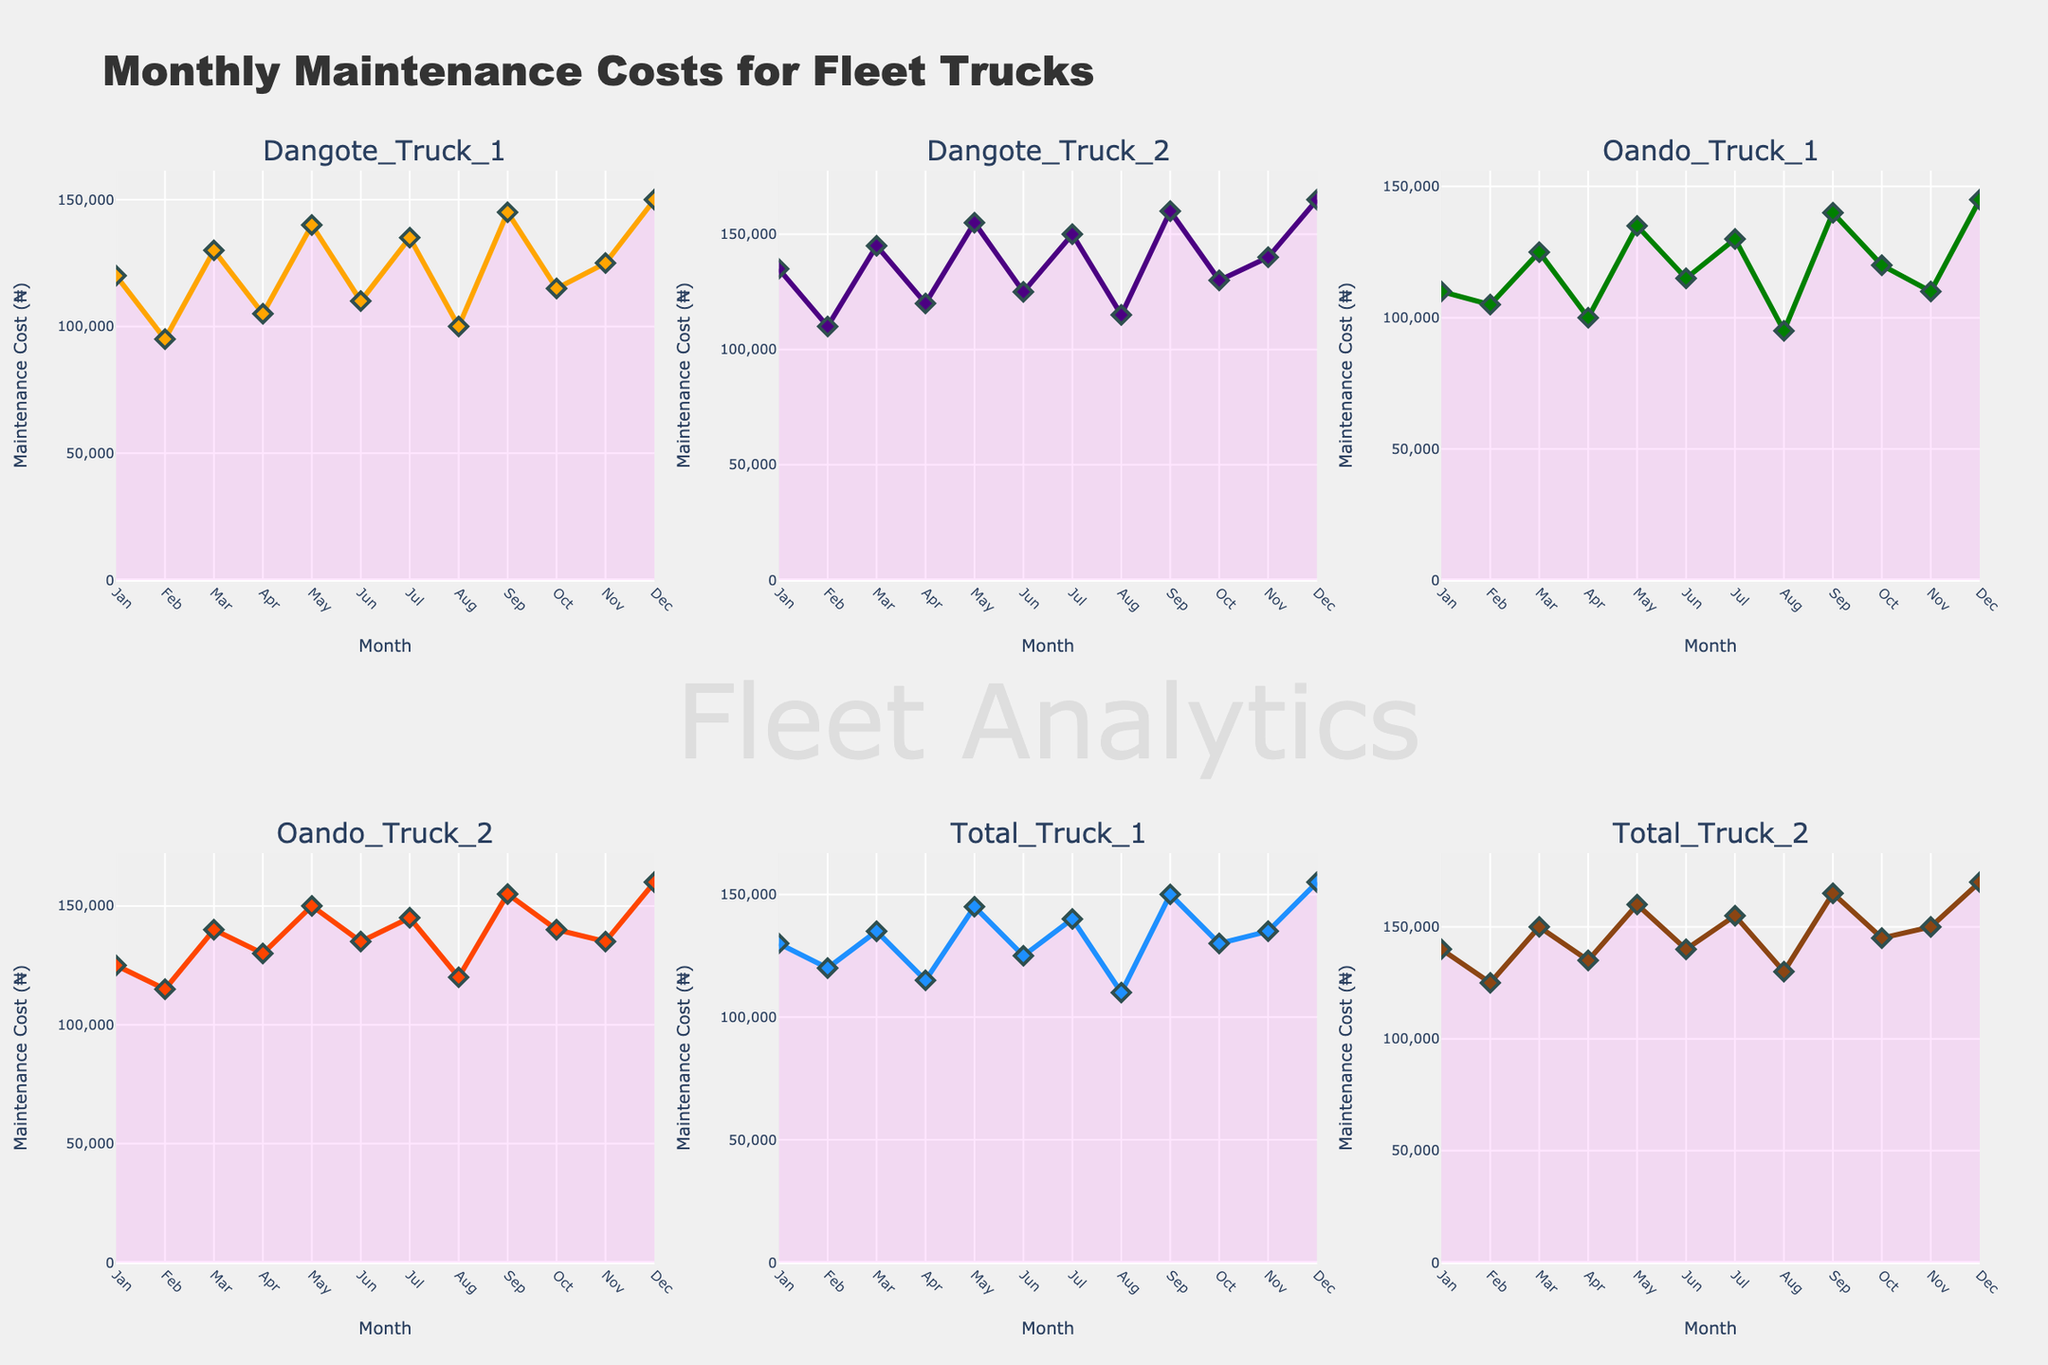What's the title of the chart? The title of the chart can be found at the top of the figure. In this case, it reads "Monthly Maintenance Costs for Fleet Trucks".
Answer: Monthly Maintenance Costs for Fleet Trucks Which truck had the highest maintenance cost in December? By looking at the subplot for December and comparing the values for each truck, you will see that "Total_Truck_2" shows the highest maintenance cost.
Answer: Total_Truck_2 What is the general trend of "Dangote_Truck_1" maintenance cost over the year? Observe the "Dangote_Truck_1" subplot and trace the line from January to December. The trend shows fluctuations, with costs peaking in March and lowest in February and August.
Answer: Fluctuating with peaks in March and lowest in February and August Between March and June, which truck had a more significant decrease in maintenance costs, "Oando_Truck_2" or "Total_Truck_2"? Calculate the difference in maintenance costs for both trucks between March and June. "Oando_Truck_2" drops from 140,000 to 135,000 (5,000), whereas "Total_Truck_2" drops from 150,000 to 140,000 (10,000).
Answer: Total_Truck_2 Which months had the lowest maintenance costs for "Total_Truck_1"? Examine the "Total_Truck_1" subplot and identify the months with the smallest y-values. "Total_Truck_1" has the lowest costs in February and August.
Answer: February and August How do the maintenance costs of the two "Oando" trucks compare in May? Compare the maintenance cost values for "Oando_Truck_1" and "Oando_Truck_2" in the May subplot. "Oando_Truck_1" has 135,000, and "Oando_Truck_2" has 150,000.
Answer: Oando_Truck_2 is higher What is the average maintenance cost for "Dangote_Truck_2" over the year? Sum up the monthly costs for "Dangote_Truck_2" and divide by the number of months (12). The total is 155,000 + 110,000 + 145,000 + 120,000 + 155,000 + 125,000 + 150,000 + 115,000 + 160,000 + 130,000 + 140,000 + 165,000 = 1,670,000. The average is 1,670,000 / 12.
Answer: 139,167 Which truck had the most considerable increase in maintenance costs from August to September? Calculate the increase for each truck by subtracting the August cost from the September cost. Identify the truck with the highest increase. "Oando_Truck_1" goes from 95,000 to 140,000 (45,000 increase).
Answer: Oando_Truck_1 What's the highest maintenance cost recorded for any truck over the year, and in which month? Inspect all subplots and identify the highest value. "Total_Truck_2" in December reports the highest cost at 170,000.
Answer: 170,000 in December What's the combined maintenance cost for "Dangote_Truck_1" and "Dangote_Truck_2" in July? Add the maintenance costs for both trucks in July. "Dangote_Truck_1" has 135,000, and "Dangote_Truck_2" has 150,000. The combined cost is 135,000 + 150,000.
Answer: 285,000 